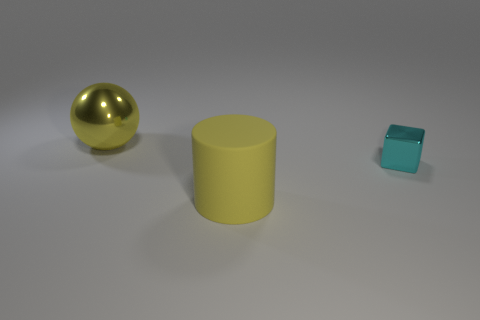How many objects are in the image, and can you describe their shapes? There are three objects in the image. From left to right, the first is a sphere with a reflective gold surface, the second is a large cylinder with a matte yellow surface, and the third is a small cube with a slightly reflective teal surface. 